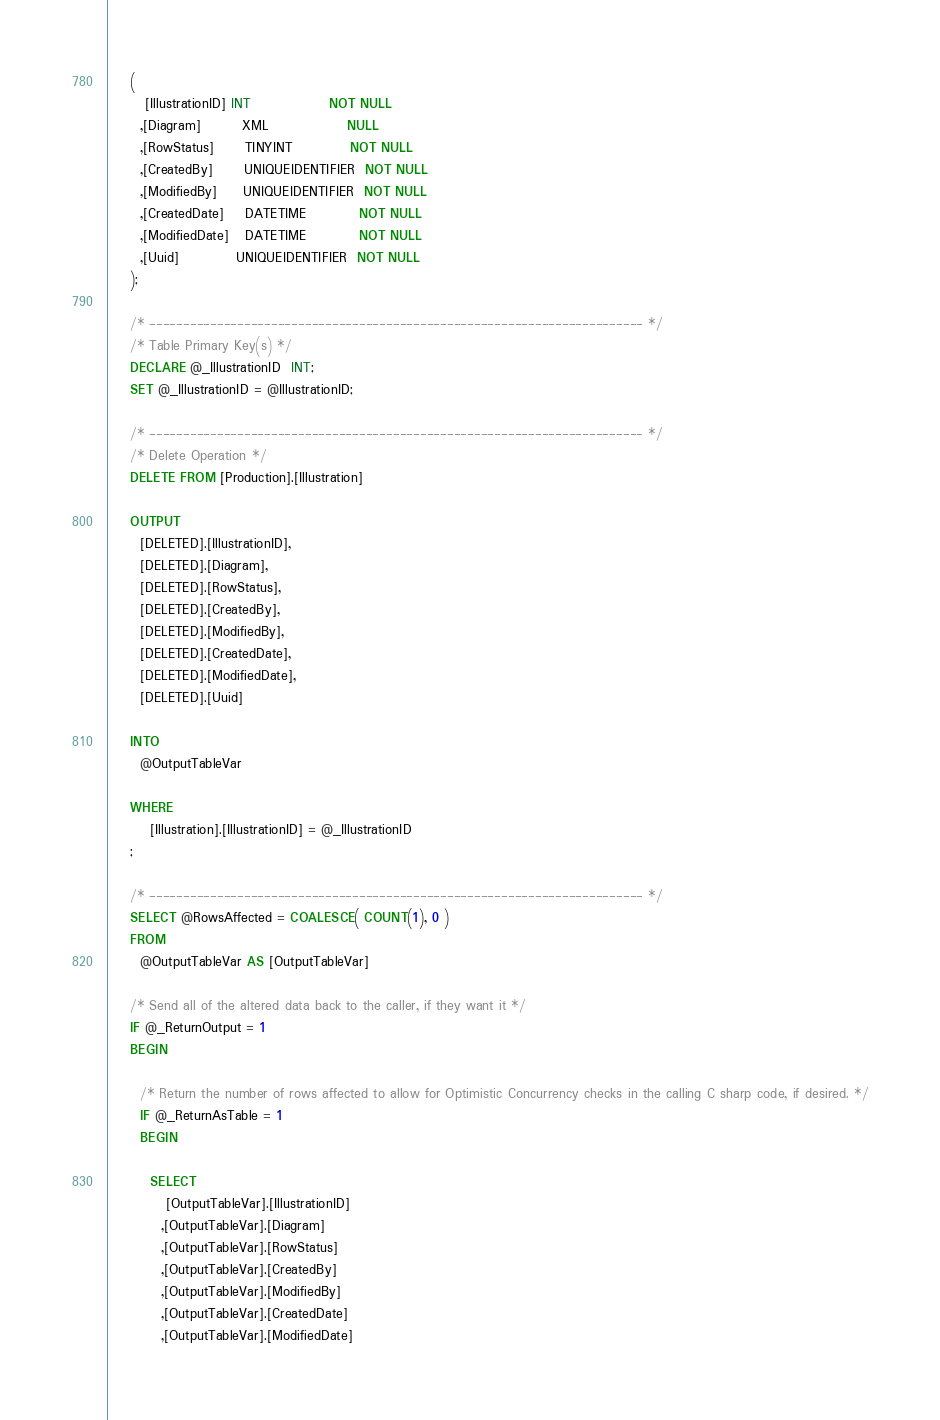<code> <loc_0><loc_0><loc_500><loc_500><_SQL_>    (
       [IllustrationID] INT               NOT NULL
      ,[Diagram]        XML               NULL
      ,[RowStatus]      TINYINT           NOT NULL
      ,[CreatedBy]      UNIQUEIDENTIFIER  NOT NULL
      ,[ModifiedBy]     UNIQUEIDENTIFIER  NOT NULL
      ,[CreatedDate]    DATETIME          NOT NULL
      ,[ModifiedDate]   DATETIME          NOT NULL
      ,[Uuid]           UNIQUEIDENTIFIER  NOT NULL
    );

    /* ------------------------------------------------------------------------- */
    /* Table Primary Key(s) */
    DECLARE @_IllustrationID  INT;
    SET @_IllustrationID = @IllustrationID;

    /* ------------------------------------------------------------------------- */
    /* Delete Operation */
    DELETE FROM [Production].[Illustration]

    OUTPUT
      [DELETED].[IllustrationID],
      [DELETED].[Diagram],
      [DELETED].[RowStatus],
      [DELETED].[CreatedBy],
      [DELETED].[ModifiedBy],
      [DELETED].[CreatedDate],
      [DELETED].[ModifiedDate],
      [DELETED].[Uuid]

    INTO
      @OutputTableVar

    WHERE
        [Illustration].[IllustrationID] = @_IllustrationID
    ;

    /* ------------------------------------------------------------------------- */
    SELECT @RowsAffected = COALESCE( COUNT(1), 0 )
    FROM
      @OutputTableVar AS [OutputTableVar]

    /* Send all of the altered data back to the caller, if they want it */
    IF @_ReturnOutput = 1
    BEGIN

      /* Return the number of rows affected to allow for Optimistic Concurrency checks in the calling C sharp code, if desired. */
      IF @_ReturnAsTable = 1
      BEGIN

        SELECT
           [OutputTableVar].[IllustrationID]
          ,[OutputTableVar].[Diagram]
          ,[OutputTableVar].[RowStatus]
          ,[OutputTableVar].[CreatedBy]
          ,[OutputTableVar].[ModifiedBy]
          ,[OutputTableVar].[CreatedDate]
          ,[OutputTableVar].[ModifiedDate]</code> 